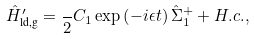<formula> <loc_0><loc_0><loc_500><loc_500>\hat { H } _ { \text {ld,g} } ^ { \prime } = \frac { } { 2 } C _ { 1 } \exp \left ( - i \epsilon t \right ) \hat { \Sigma } _ { 1 } ^ { + } + H . c . ,</formula> 